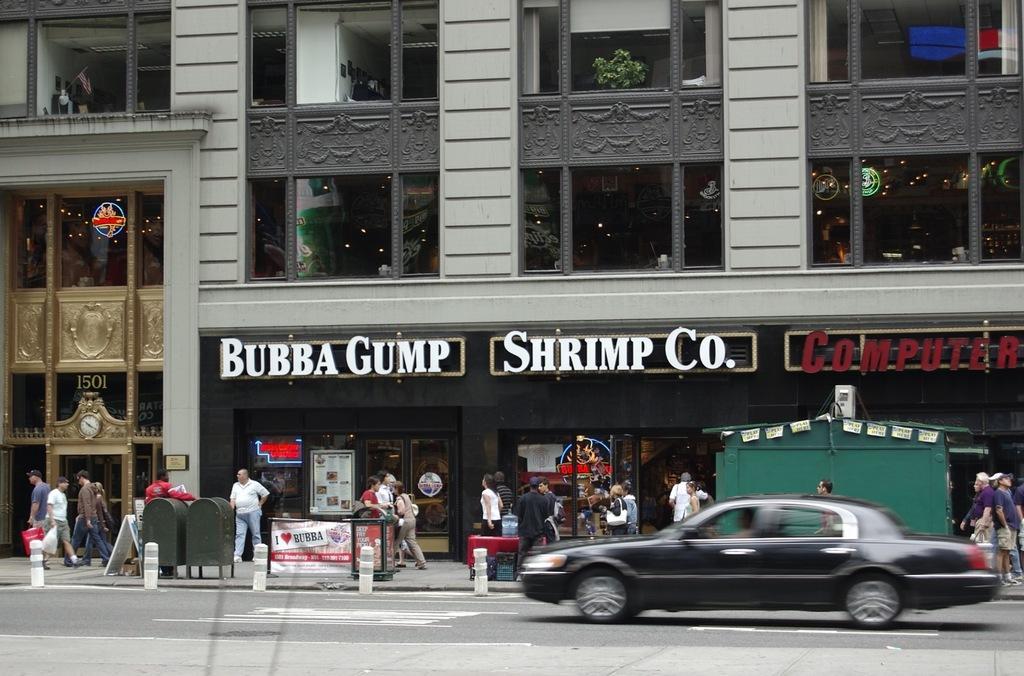In one or two sentences, can you explain what this image depicts? In this image I can see the car in black color and I can see few people, some are standing and some are walking, few stores, glass doors and I can also see the building in gray color and few boards attached to the building. 